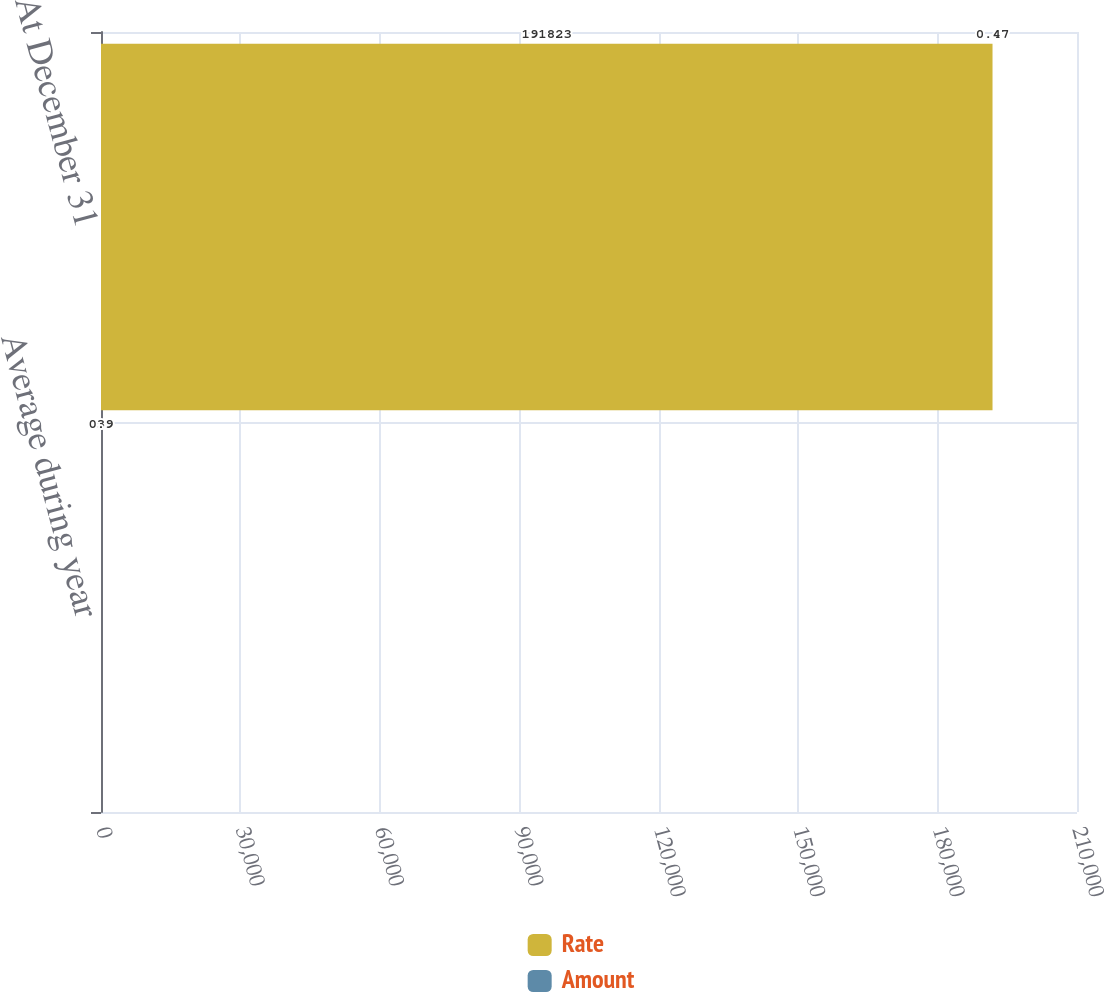Convert chart. <chart><loc_0><loc_0><loc_500><loc_500><stacked_bar_chart><ecel><fcel>Average during year<fcel>At December 31<nl><fcel>Rate<fcel>3<fcel>191823<nl><fcel>Amount<fcel>0.9<fcel>0.47<nl></chart> 